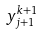Convert formula to latex. <formula><loc_0><loc_0><loc_500><loc_500>y _ { j + 1 } ^ { k + 1 }</formula> 